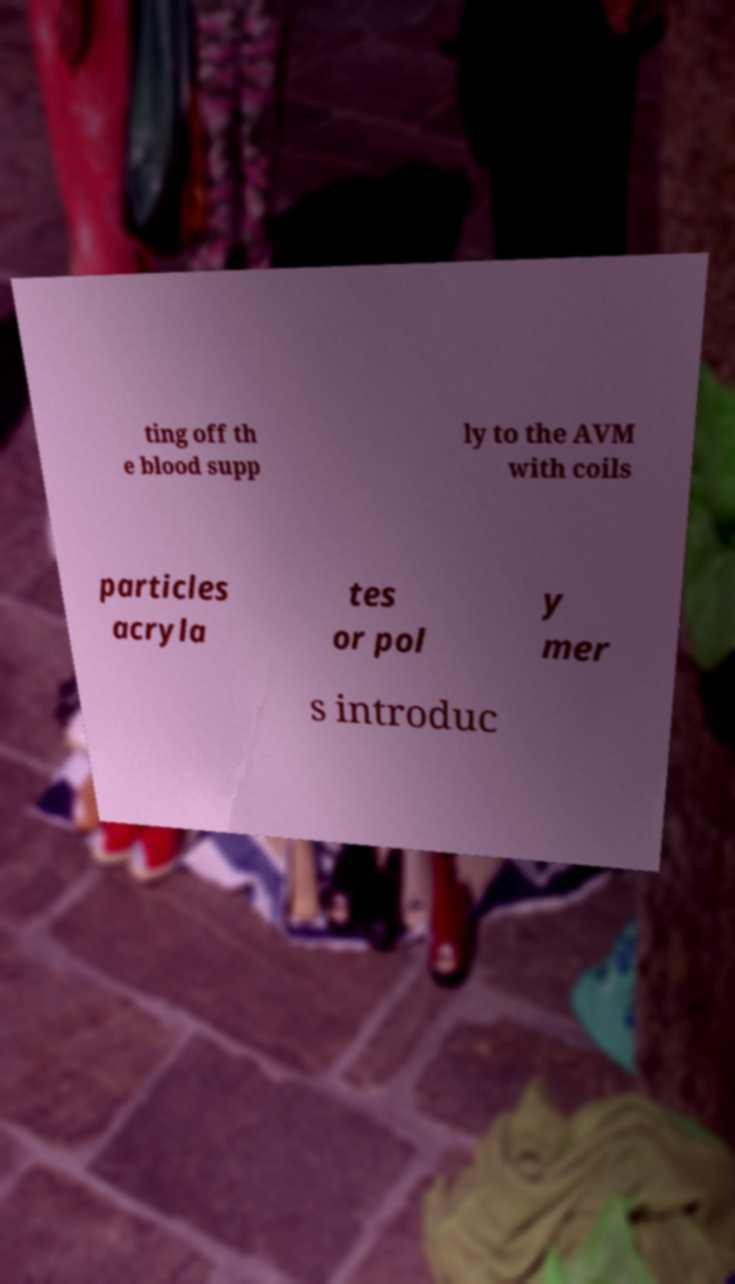Could you assist in decoding the text presented in this image and type it out clearly? ting off th e blood supp ly to the AVM with coils particles acryla tes or pol y mer s introduc 